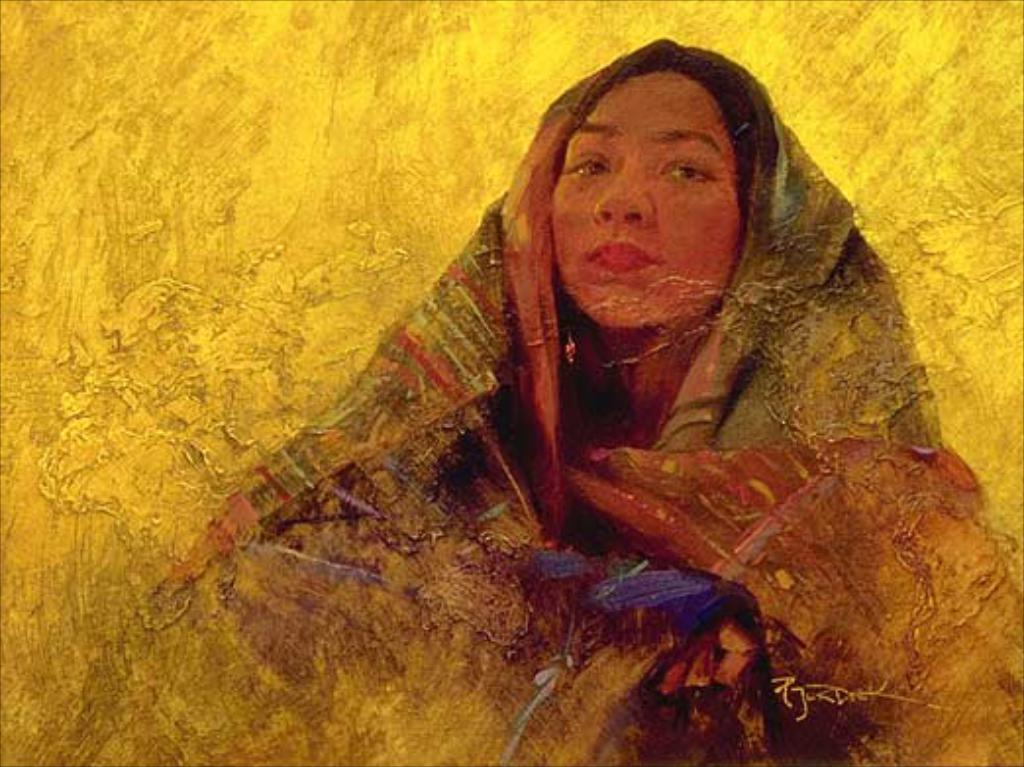What is the main subject of the image? The image contains a painting. What is depicted in the painting? The painting depicts a woman. What can be observed about the woman's attire in the painting? The woman is wearing a dress with green, orange, violet, and gold colors. What is the color of the painting's surface? The surface of the painting is gold colored. Are there any cherries hanging from the woman's dress in the painting? There are no cherries depicted in the painting; the woman's dress features green, orange, violet, and gold colors. Is there a cave visible in the background of the painting? There is no cave depicted in the painting; the background is not mentioned in the provided facts. 